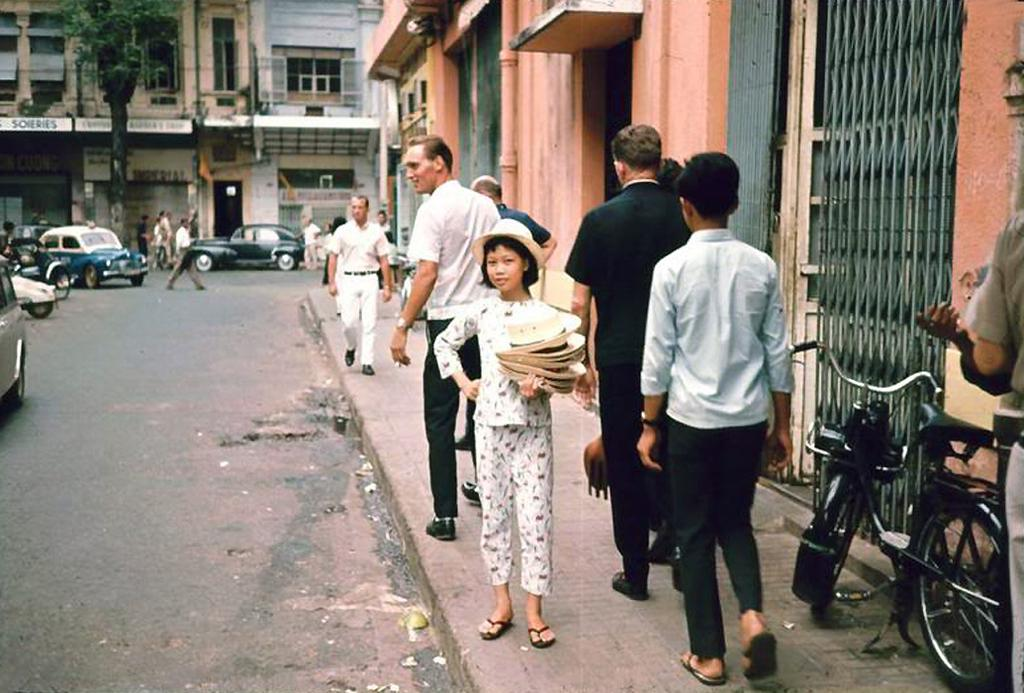What can be seen on the footpath in the image? There is a group of people on the footpath in the image. What else is visible in the image besides the people on the footpath? There are vehicles and people on the road in the image. Can you describe the natural element in the image? There is a tree in the image. What else can be seen in the image? There are objects and buildings with windows in the background. What season is depicted in the image? The provided facts do not mention any specific season or weather conditions, so it cannot be determined from the image. What effect does the class have on the people in the image? There is no mention of a class or any educational setting in the image, so it cannot be determined how it might affect the people. 